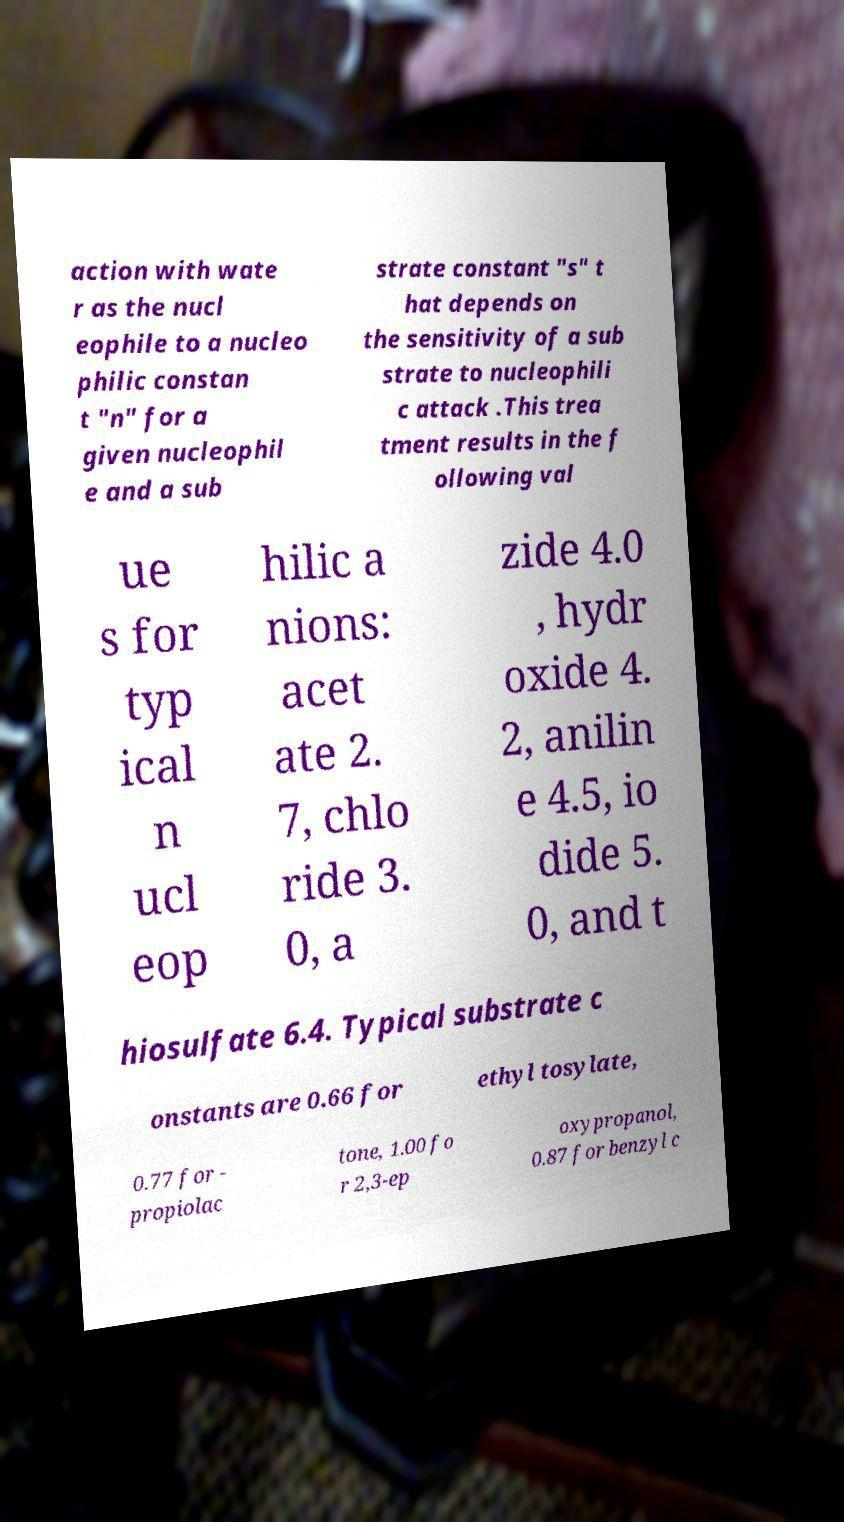Please read and relay the text visible in this image. What does it say? action with wate r as the nucl eophile to a nucleo philic constan t "n" for a given nucleophil e and a sub strate constant "s" t hat depends on the sensitivity of a sub strate to nucleophili c attack .This trea tment results in the f ollowing val ue s for typ ical n ucl eop hilic a nions: acet ate 2. 7, chlo ride 3. 0, a zide 4.0 , hydr oxide 4. 2, anilin e 4.5, io dide 5. 0, and t hiosulfate 6.4. Typical substrate c onstants are 0.66 for ethyl tosylate, 0.77 for - propiolac tone, 1.00 fo r 2,3-ep oxypropanol, 0.87 for benzyl c 